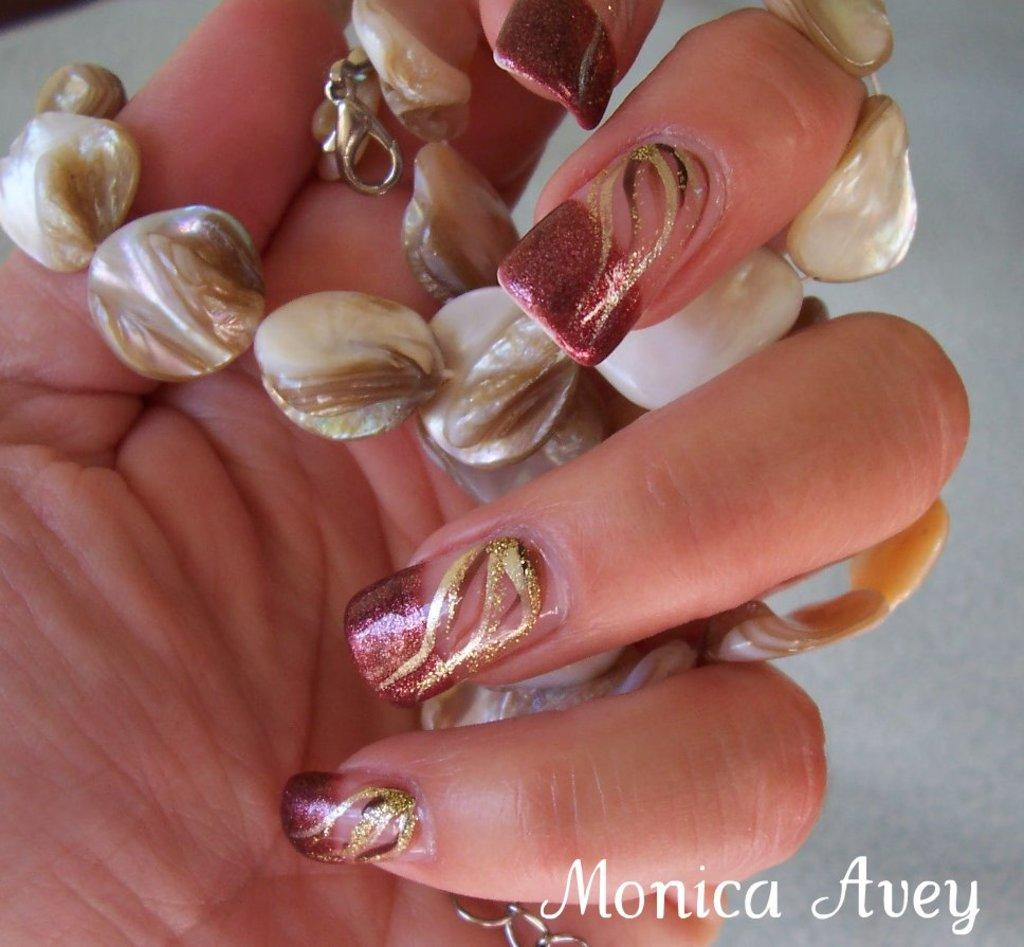<image>
Relay a brief, clear account of the picture shown. A close up picture of a nice manicured painted nails holding a necklace that says Monica Avey in the bottom corner. 